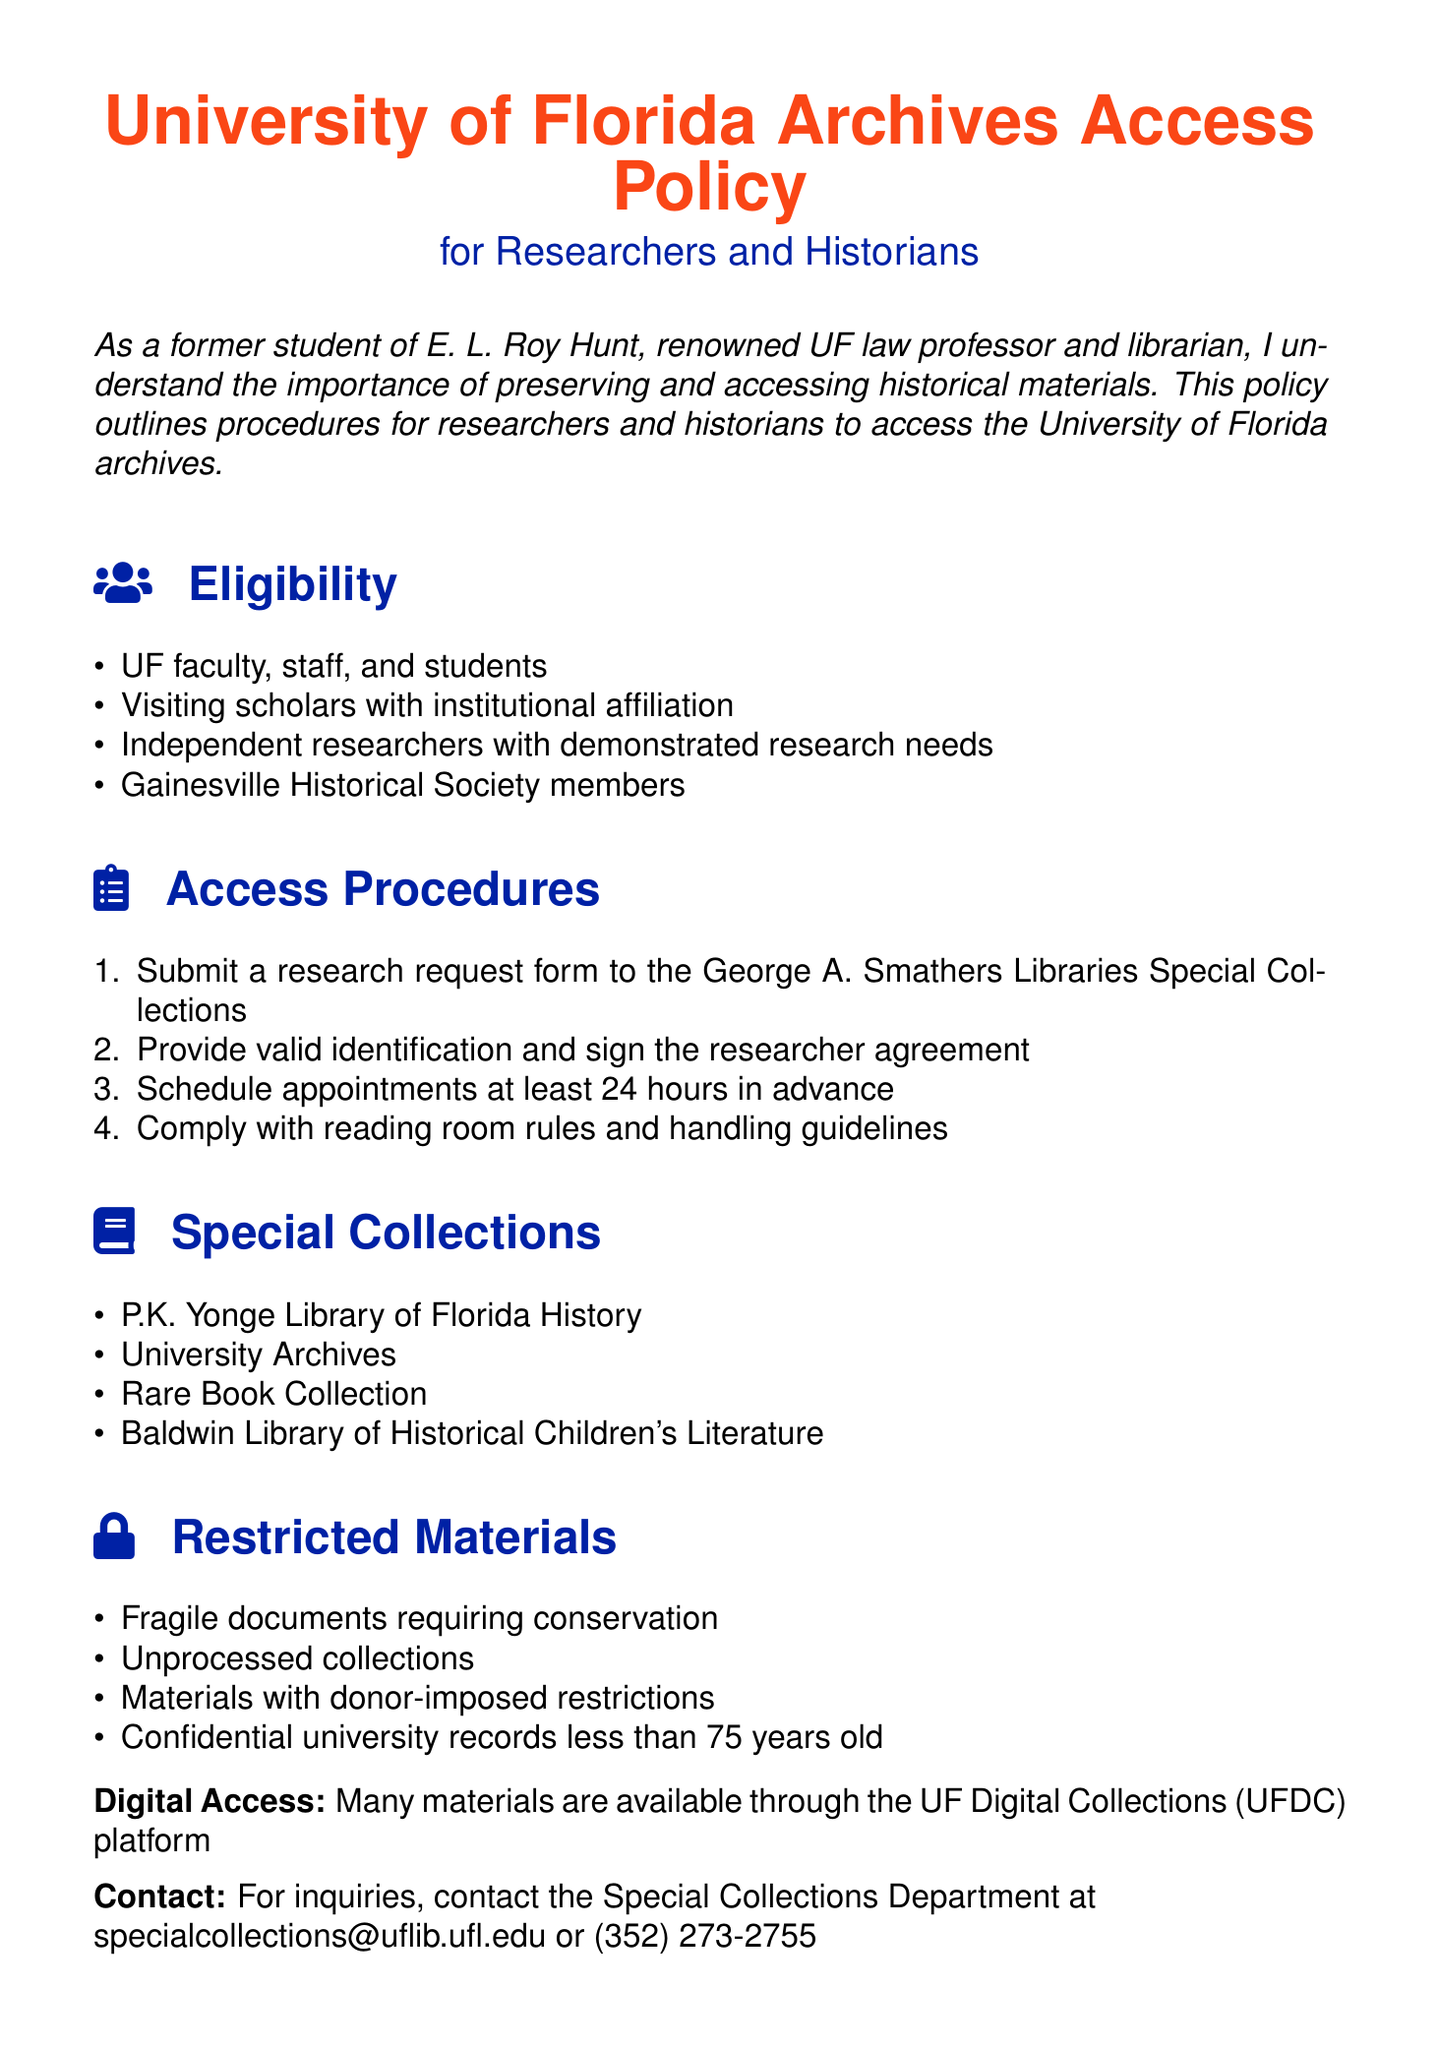What is the eligibility criteria for accessing the archives? The eligibility criteria include UF faculty, staff, and students, visiting scholars with institutional affiliation, independent researchers with demonstrated research needs, and Gainesville Historical Society members.
Answer: UF faculty, staff, students, visiting scholars, independent researchers, Gainesville Historical Society members What is the first step in the access procedures? The first step outlined in the document for accessing the archives is submitting a research request form to the George A. Smathers Libraries Special Collections.
Answer: Submit a research request form How much advance notice is required to schedule appointments? The policy specifies that appointments must be scheduled at least 24 hours in advance.
Answer: 24 hours Name one type of material that is restricted. The document lists fragile documents requiring conservation as one of the restricted materials.
Answer: Fragile documents What contact information is provided for inquiries? The document provides contact details for the Special Collections Department through email and phone number.
Answer: specialcollections@uflib.ufl.edu or (352) 273-2755 How does the document categorize materials for access? The policy categorizes materials into eligibility, access procedures, special collections, and restricted materials.
Answer: Eligibility, access procedures, special collections, restricted materials 